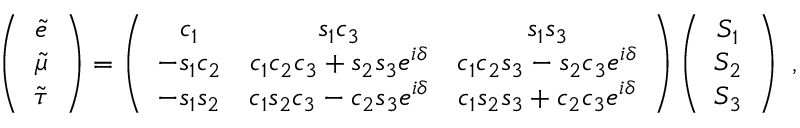<formula> <loc_0><loc_0><loc_500><loc_500>\left ( \begin{array} { c } { { \tilde { e } } } \\ { { \tilde { \mu } } } \\ { { \tilde { \tau } } } \end{array} \right ) = \left ( \begin{array} { c c c } { { c _ { 1 } } } & { { s _ { 1 } c _ { 3 } } } & { { s _ { 1 } s _ { 3 } } } \\ { { - s _ { 1 } c _ { 2 } } } & { { c _ { 1 } c _ { 2 } c _ { 3 } + s _ { 2 } s _ { 3 } e ^ { i \delta } } } & { { c _ { 1 } c _ { 2 } s _ { 3 } - s _ { 2 } c _ { 3 } e ^ { i \delta } } } \\ { { - s _ { 1 } s _ { 2 } } } & { { c _ { 1 } s _ { 2 } c _ { 3 } - c _ { 2 } s _ { 3 } e ^ { i \delta } } } & { { c _ { 1 } s _ { 2 } s _ { 3 } + c _ { 2 } c _ { 3 } e ^ { i \delta } } } \end{array} \right ) \left ( \begin{array} { c } { { S _ { 1 } } } \\ { { S _ { 2 } } } \\ { { S _ { 3 } } } \end{array} \right ) \ ,</formula> 